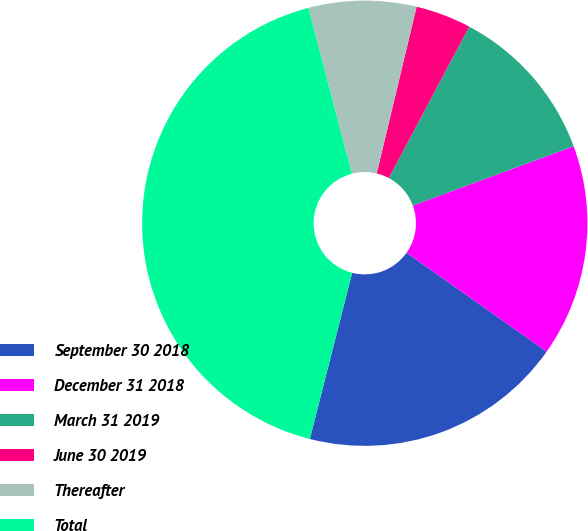Convert chart to OTSL. <chart><loc_0><loc_0><loc_500><loc_500><pie_chart><fcel>September 30 2018<fcel>December 31 2018<fcel>March 31 2019<fcel>June 30 2019<fcel>Thereafter<fcel>Total<nl><fcel>19.19%<fcel>15.4%<fcel>11.61%<fcel>4.03%<fcel>7.82%<fcel>41.95%<nl></chart> 